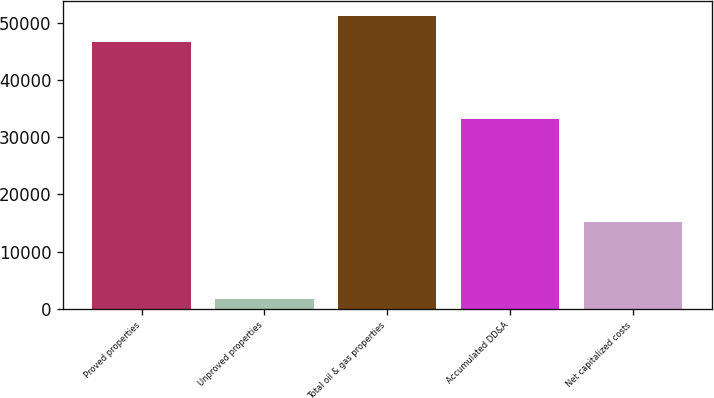Convert chart. <chart><loc_0><loc_0><loc_500><loc_500><bar_chart><fcel>Proved properties<fcel>Unproved properties<fcel>Total oil & gas properties<fcel>Accumulated DD&A<fcel>Net capitalized costs<nl><fcel>46570<fcel>1703<fcel>51227<fcel>33098<fcel>15175<nl></chart> 